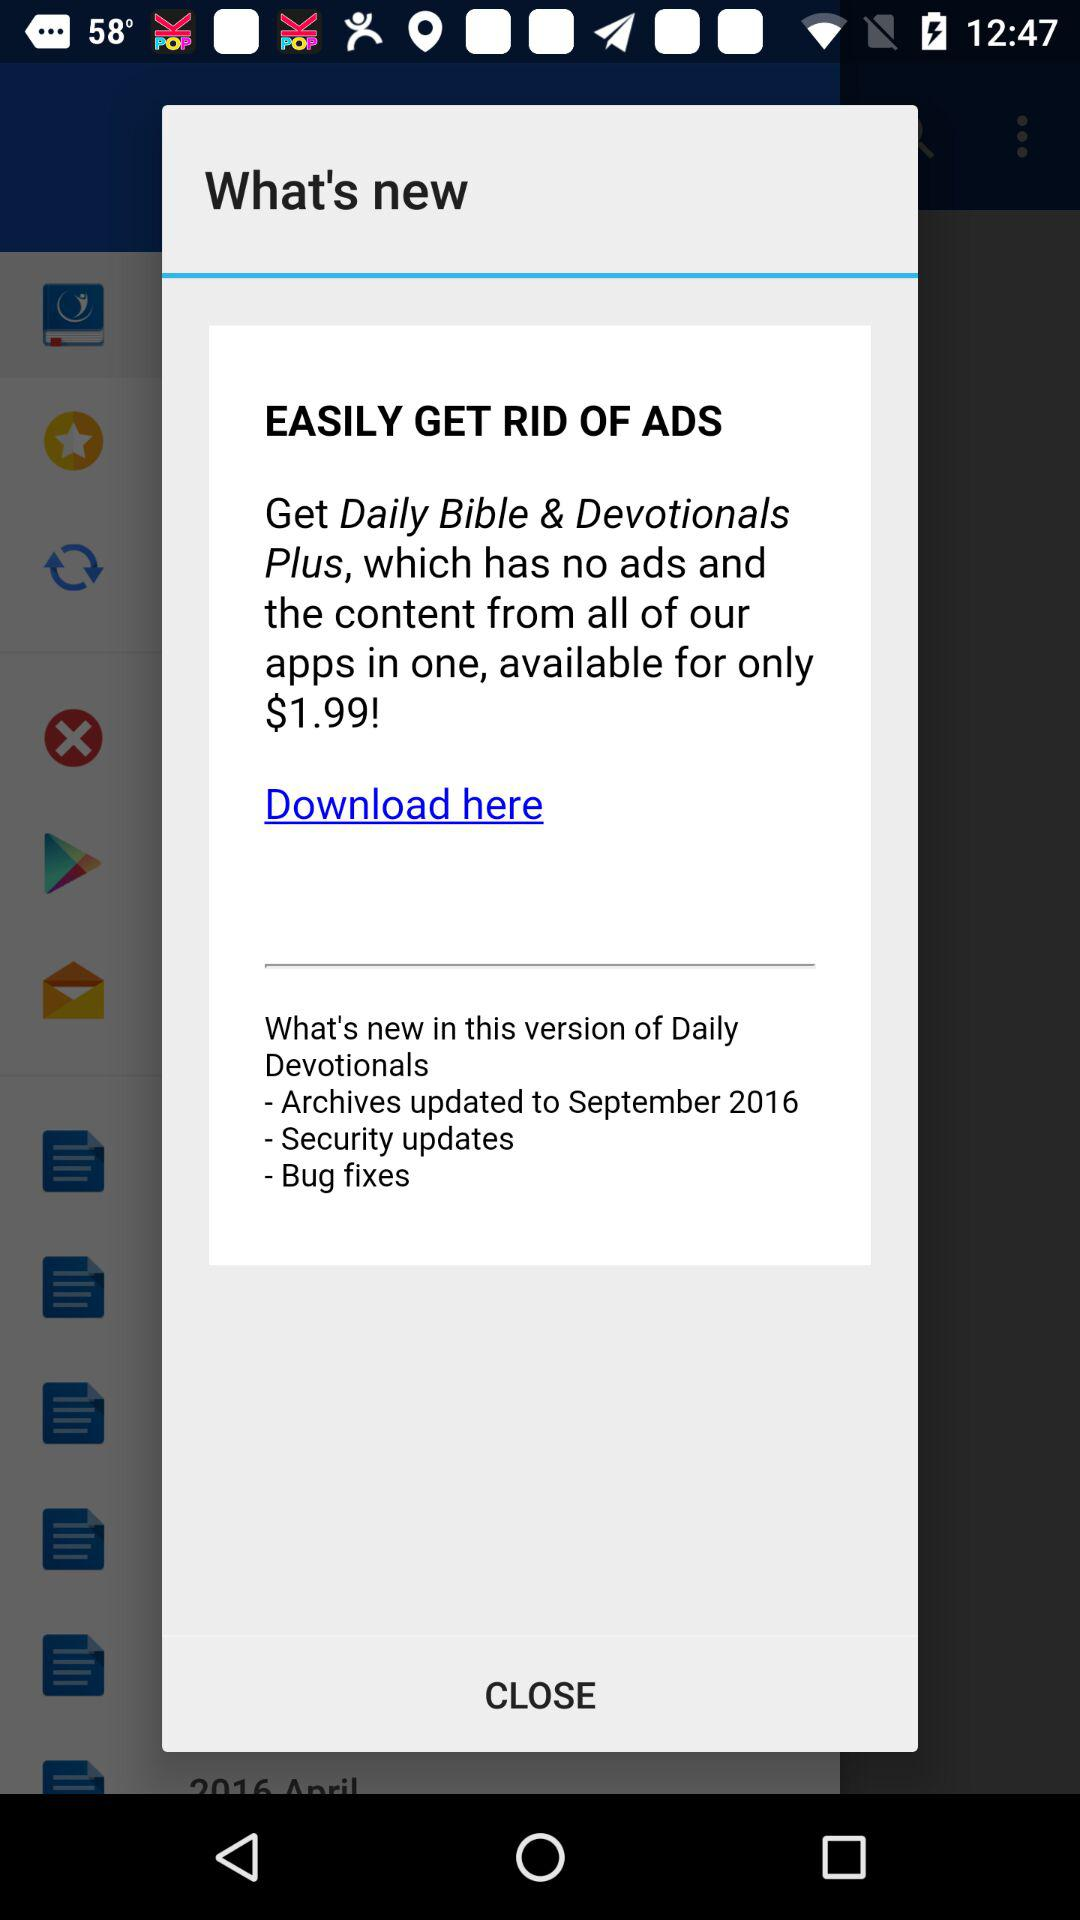What is the price of the app? The price of the app is $1.99. 